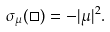<formula> <loc_0><loc_0><loc_500><loc_500>\sigma _ { \mu } ( \Box ) = - | \mu | ^ { 2 } .</formula> 